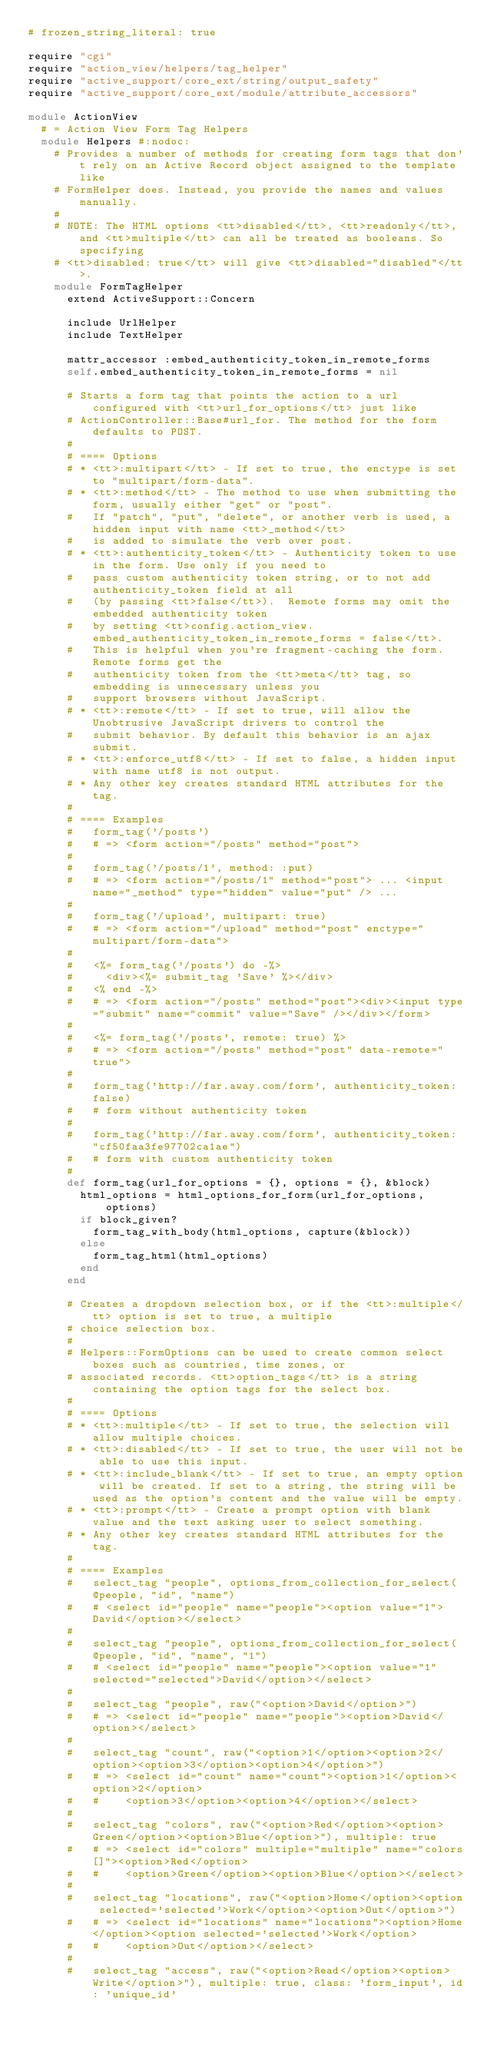Convert code to text. <code><loc_0><loc_0><loc_500><loc_500><_Ruby_># frozen_string_literal: true

require "cgi"
require "action_view/helpers/tag_helper"
require "active_support/core_ext/string/output_safety"
require "active_support/core_ext/module/attribute_accessors"

module ActionView
  # = Action View Form Tag Helpers
  module Helpers #:nodoc:
    # Provides a number of methods for creating form tags that don't rely on an Active Record object assigned to the template like
    # FormHelper does. Instead, you provide the names and values manually.
    #
    # NOTE: The HTML options <tt>disabled</tt>, <tt>readonly</tt>, and <tt>multiple</tt> can all be treated as booleans. So specifying
    # <tt>disabled: true</tt> will give <tt>disabled="disabled"</tt>.
    module FormTagHelper
      extend ActiveSupport::Concern

      include UrlHelper
      include TextHelper

      mattr_accessor :embed_authenticity_token_in_remote_forms
      self.embed_authenticity_token_in_remote_forms = nil

      # Starts a form tag that points the action to a url configured with <tt>url_for_options</tt> just like
      # ActionController::Base#url_for. The method for the form defaults to POST.
      #
      # ==== Options
      # * <tt>:multipart</tt> - If set to true, the enctype is set to "multipart/form-data".
      # * <tt>:method</tt> - The method to use when submitting the form, usually either "get" or "post".
      #   If "patch", "put", "delete", or another verb is used, a hidden input with name <tt>_method</tt>
      #   is added to simulate the verb over post.
      # * <tt>:authenticity_token</tt> - Authenticity token to use in the form. Use only if you need to
      #   pass custom authenticity token string, or to not add authenticity_token field at all
      #   (by passing <tt>false</tt>).  Remote forms may omit the embedded authenticity token
      #   by setting <tt>config.action_view.embed_authenticity_token_in_remote_forms = false</tt>.
      #   This is helpful when you're fragment-caching the form. Remote forms get the
      #   authenticity token from the <tt>meta</tt> tag, so embedding is unnecessary unless you
      #   support browsers without JavaScript.
      # * <tt>:remote</tt> - If set to true, will allow the Unobtrusive JavaScript drivers to control the
      #   submit behavior. By default this behavior is an ajax submit.
      # * <tt>:enforce_utf8</tt> - If set to false, a hidden input with name utf8 is not output.
      # * Any other key creates standard HTML attributes for the tag.
      #
      # ==== Examples
      #   form_tag('/posts')
      #   # => <form action="/posts" method="post">
      #
      #   form_tag('/posts/1', method: :put)
      #   # => <form action="/posts/1" method="post"> ... <input name="_method" type="hidden" value="put" /> ...
      #
      #   form_tag('/upload', multipart: true)
      #   # => <form action="/upload" method="post" enctype="multipart/form-data">
      #
      #   <%= form_tag('/posts') do -%>
      #     <div><%= submit_tag 'Save' %></div>
      #   <% end -%>
      #   # => <form action="/posts" method="post"><div><input type="submit" name="commit" value="Save" /></div></form>
      #
      #   <%= form_tag('/posts', remote: true) %>
      #   # => <form action="/posts" method="post" data-remote="true">
      #
      #   form_tag('http://far.away.com/form', authenticity_token: false)
      #   # form without authenticity token
      #
      #   form_tag('http://far.away.com/form', authenticity_token: "cf50faa3fe97702ca1ae")
      #   # form with custom authenticity token
      #
      def form_tag(url_for_options = {}, options = {}, &block)
        html_options = html_options_for_form(url_for_options, options)
        if block_given?
          form_tag_with_body(html_options, capture(&block))
        else
          form_tag_html(html_options)
        end
      end

      # Creates a dropdown selection box, or if the <tt>:multiple</tt> option is set to true, a multiple
      # choice selection box.
      #
      # Helpers::FormOptions can be used to create common select boxes such as countries, time zones, or
      # associated records. <tt>option_tags</tt> is a string containing the option tags for the select box.
      #
      # ==== Options
      # * <tt>:multiple</tt> - If set to true, the selection will allow multiple choices.
      # * <tt>:disabled</tt> - If set to true, the user will not be able to use this input.
      # * <tt>:include_blank</tt> - If set to true, an empty option will be created. If set to a string, the string will be used as the option's content and the value will be empty.
      # * <tt>:prompt</tt> - Create a prompt option with blank value and the text asking user to select something.
      # * Any other key creates standard HTML attributes for the tag.
      #
      # ==== Examples
      #   select_tag "people", options_from_collection_for_select(@people, "id", "name")
      #   # <select id="people" name="people"><option value="1">David</option></select>
      #
      #   select_tag "people", options_from_collection_for_select(@people, "id", "name", "1")
      #   # <select id="people" name="people"><option value="1" selected="selected">David</option></select>
      #
      #   select_tag "people", raw("<option>David</option>")
      #   # => <select id="people" name="people"><option>David</option></select>
      #
      #   select_tag "count", raw("<option>1</option><option>2</option><option>3</option><option>4</option>")
      #   # => <select id="count" name="count"><option>1</option><option>2</option>
      #   #    <option>3</option><option>4</option></select>
      #
      #   select_tag "colors", raw("<option>Red</option><option>Green</option><option>Blue</option>"), multiple: true
      #   # => <select id="colors" multiple="multiple" name="colors[]"><option>Red</option>
      #   #    <option>Green</option><option>Blue</option></select>
      #
      #   select_tag "locations", raw("<option>Home</option><option selected='selected'>Work</option><option>Out</option>")
      #   # => <select id="locations" name="locations"><option>Home</option><option selected='selected'>Work</option>
      #   #    <option>Out</option></select>
      #
      #   select_tag "access", raw("<option>Read</option><option>Write</option>"), multiple: true, class: 'form_input', id: 'unique_id'</code> 